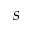Convert formula to latex. <formula><loc_0><loc_0><loc_500><loc_500>s</formula> 